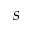Convert formula to latex. <formula><loc_0><loc_0><loc_500><loc_500>s</formula> 